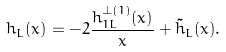Convert formula to latex. <formula><loc_0><loc_0><loc_500><loc_500>h _ { L } ( x ) = - 2 \frac { h _ { 1 L } ^ { \perp ( 1 ) } ( x ) } { x } + \tilde { h } _ { L } ( x ) .</formula> 